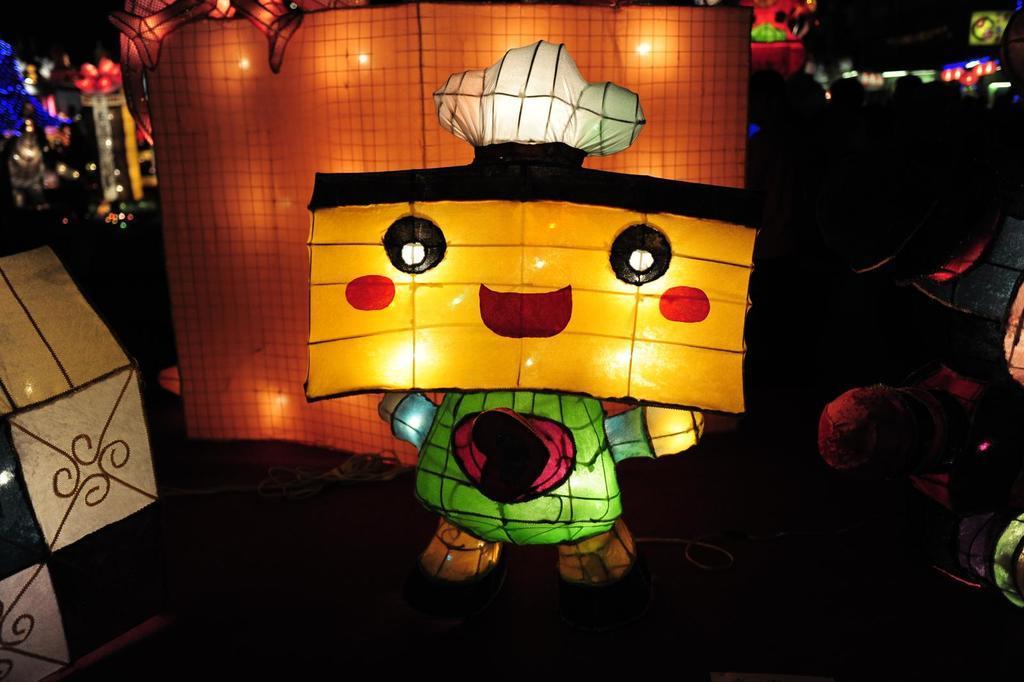In one or two sentences, can you explain what this image depicts? In this picture we can see lanterns in shape of dolls and we can see decorative objects. In the background of the image it is dark. On the left side of the image we can see an object. 